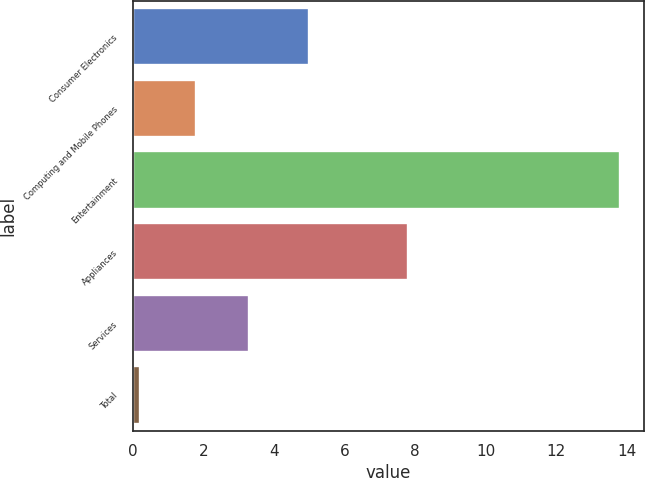Convert chart to OTSL. <chart><loc_0><loc_0><loc_500><loc_500><bar_chart><fcel>Consumer Electronics<fcel>Computing and Mobile Phones<fcel>Entertainment<fcel>Appliances<fcel>Services<fcel>Total<nl><fcel>5<fcel>1.8<fcel>13.8<fcel>7.8<fcel>3.3<fcel>0.2<nl></chart> 